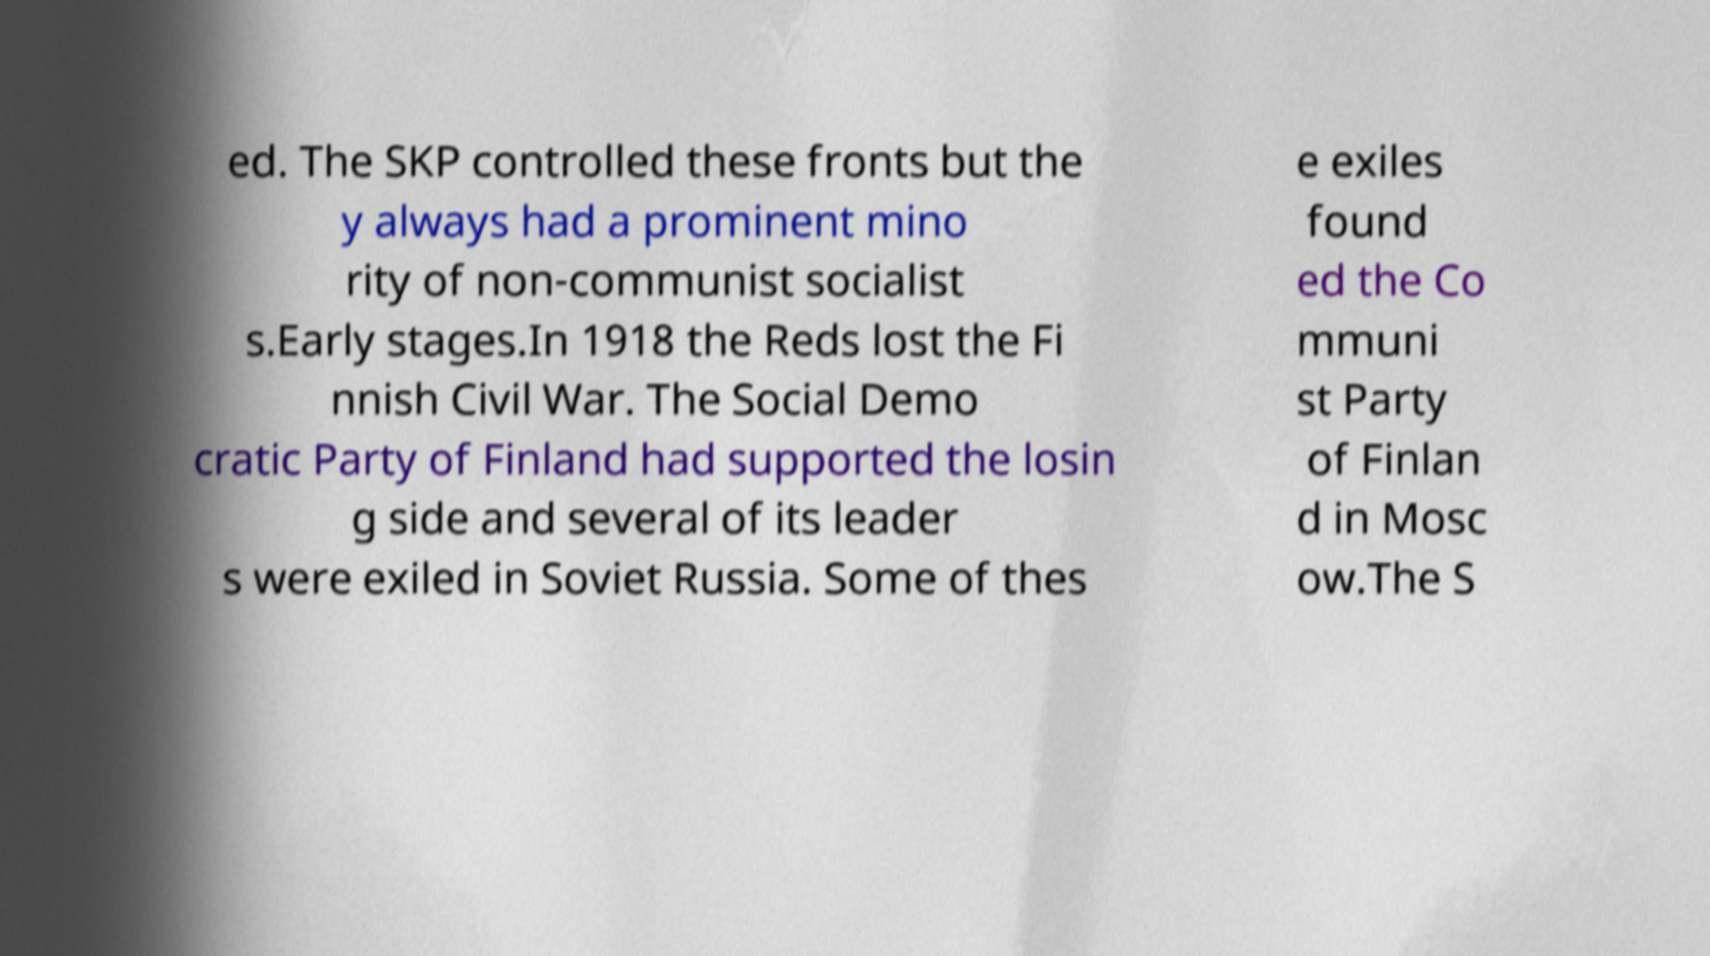For documentation purposes, I need the text within this image transcribed. Could you provide that? ed. The SKP controlled these fronts but the y always had a prominent mino rity of non-communist socialist s.Early stages.In 1918 the Reds lost the Fi nnish Civil War. The Social Demo cratic Party of Finland had supported the losin g side and several of its leader s were exiled in Soviet Russia. Some of thes e exiles found ed the Co mmuni st Party of Finlan d in Mosc ow.The S 